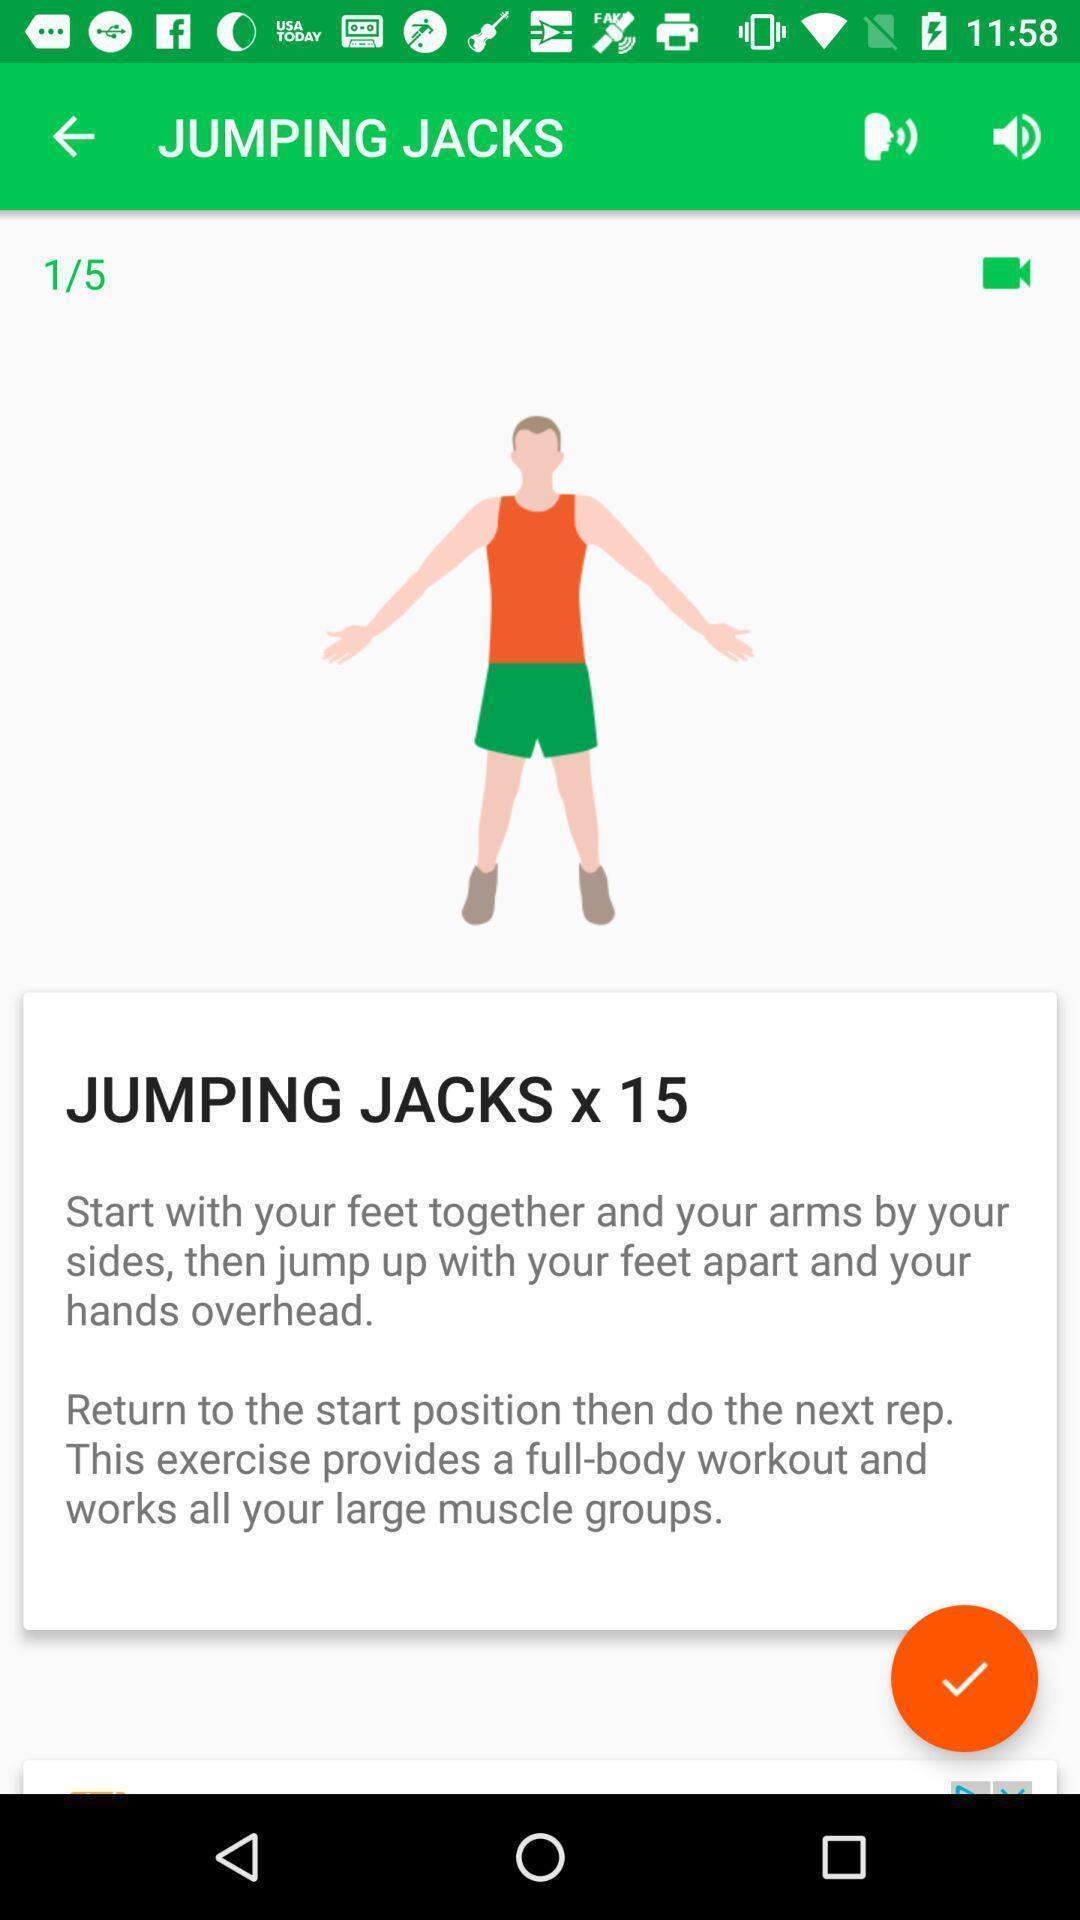Tell me about the visual elements in this screen capture. Page displaying the jumping jacks of a person. 